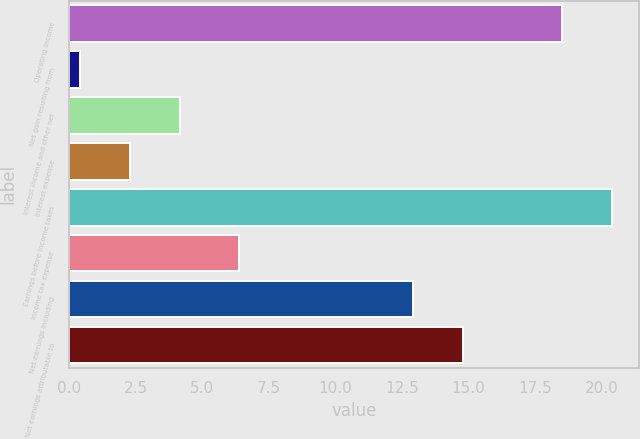Convert chart to OTSL. <chart><loc_0><loc_0><loc_500><loc_500><bar_chart><fcel>Operating income<fcel>Net gain resulting from<fcel>Interest income and other net<fcel>Interest expense<fcel>Earnings before income taxes<fcel>Income tax expense<fcel>Net earnings including<fcel>Net earnings attributable to<nl><fcel>18.5<fcel>0.4<fcel>4.18<fcel>2.29<fcel>20.39<fcel>6.4<fcel>12.9<fcel>14.79<nl></chart> 